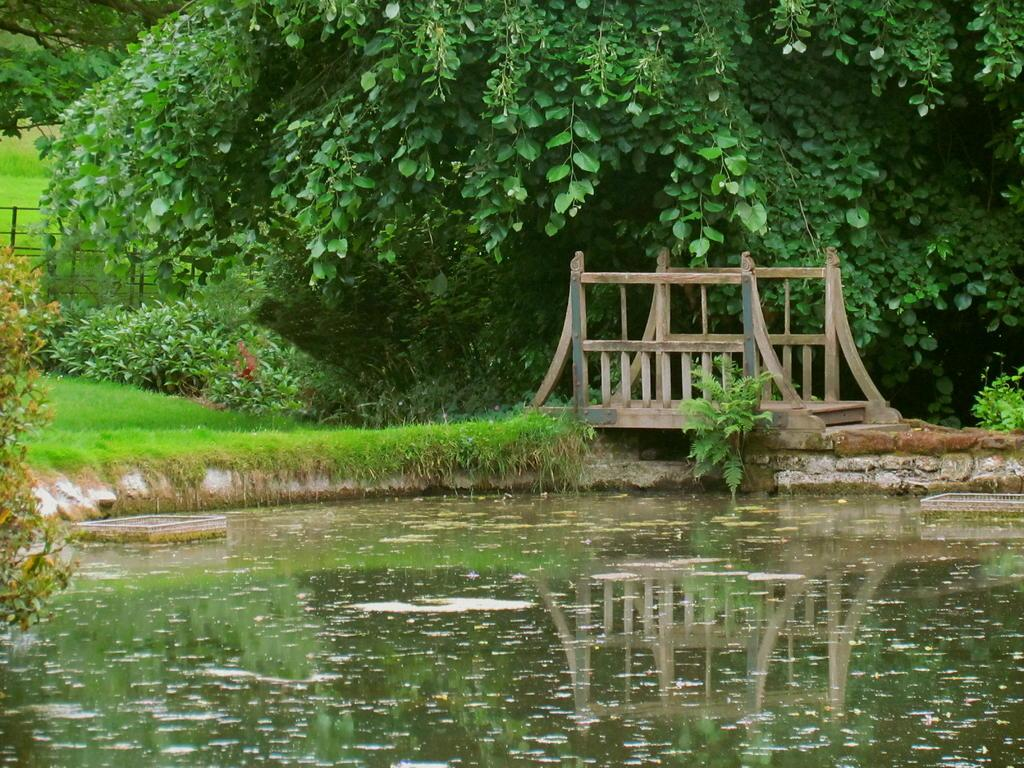What type of body of water is in the image? There is a lake in the image. What structure is located near the lake? There is a wooden bridge beside the lake. What type of vegetation is visible at the top of the image? Trees are visible at the top of the image. What type of vegetation is present in the image? Bushes are present in the image. What type of ground cover is visible in the middle of the image? Grass is visible in the middle of the image. What is the weight of the hand holding the camera in the image? There is no hand holding a camera visible in the image, so it is not possible to determine the weight of any hand. 